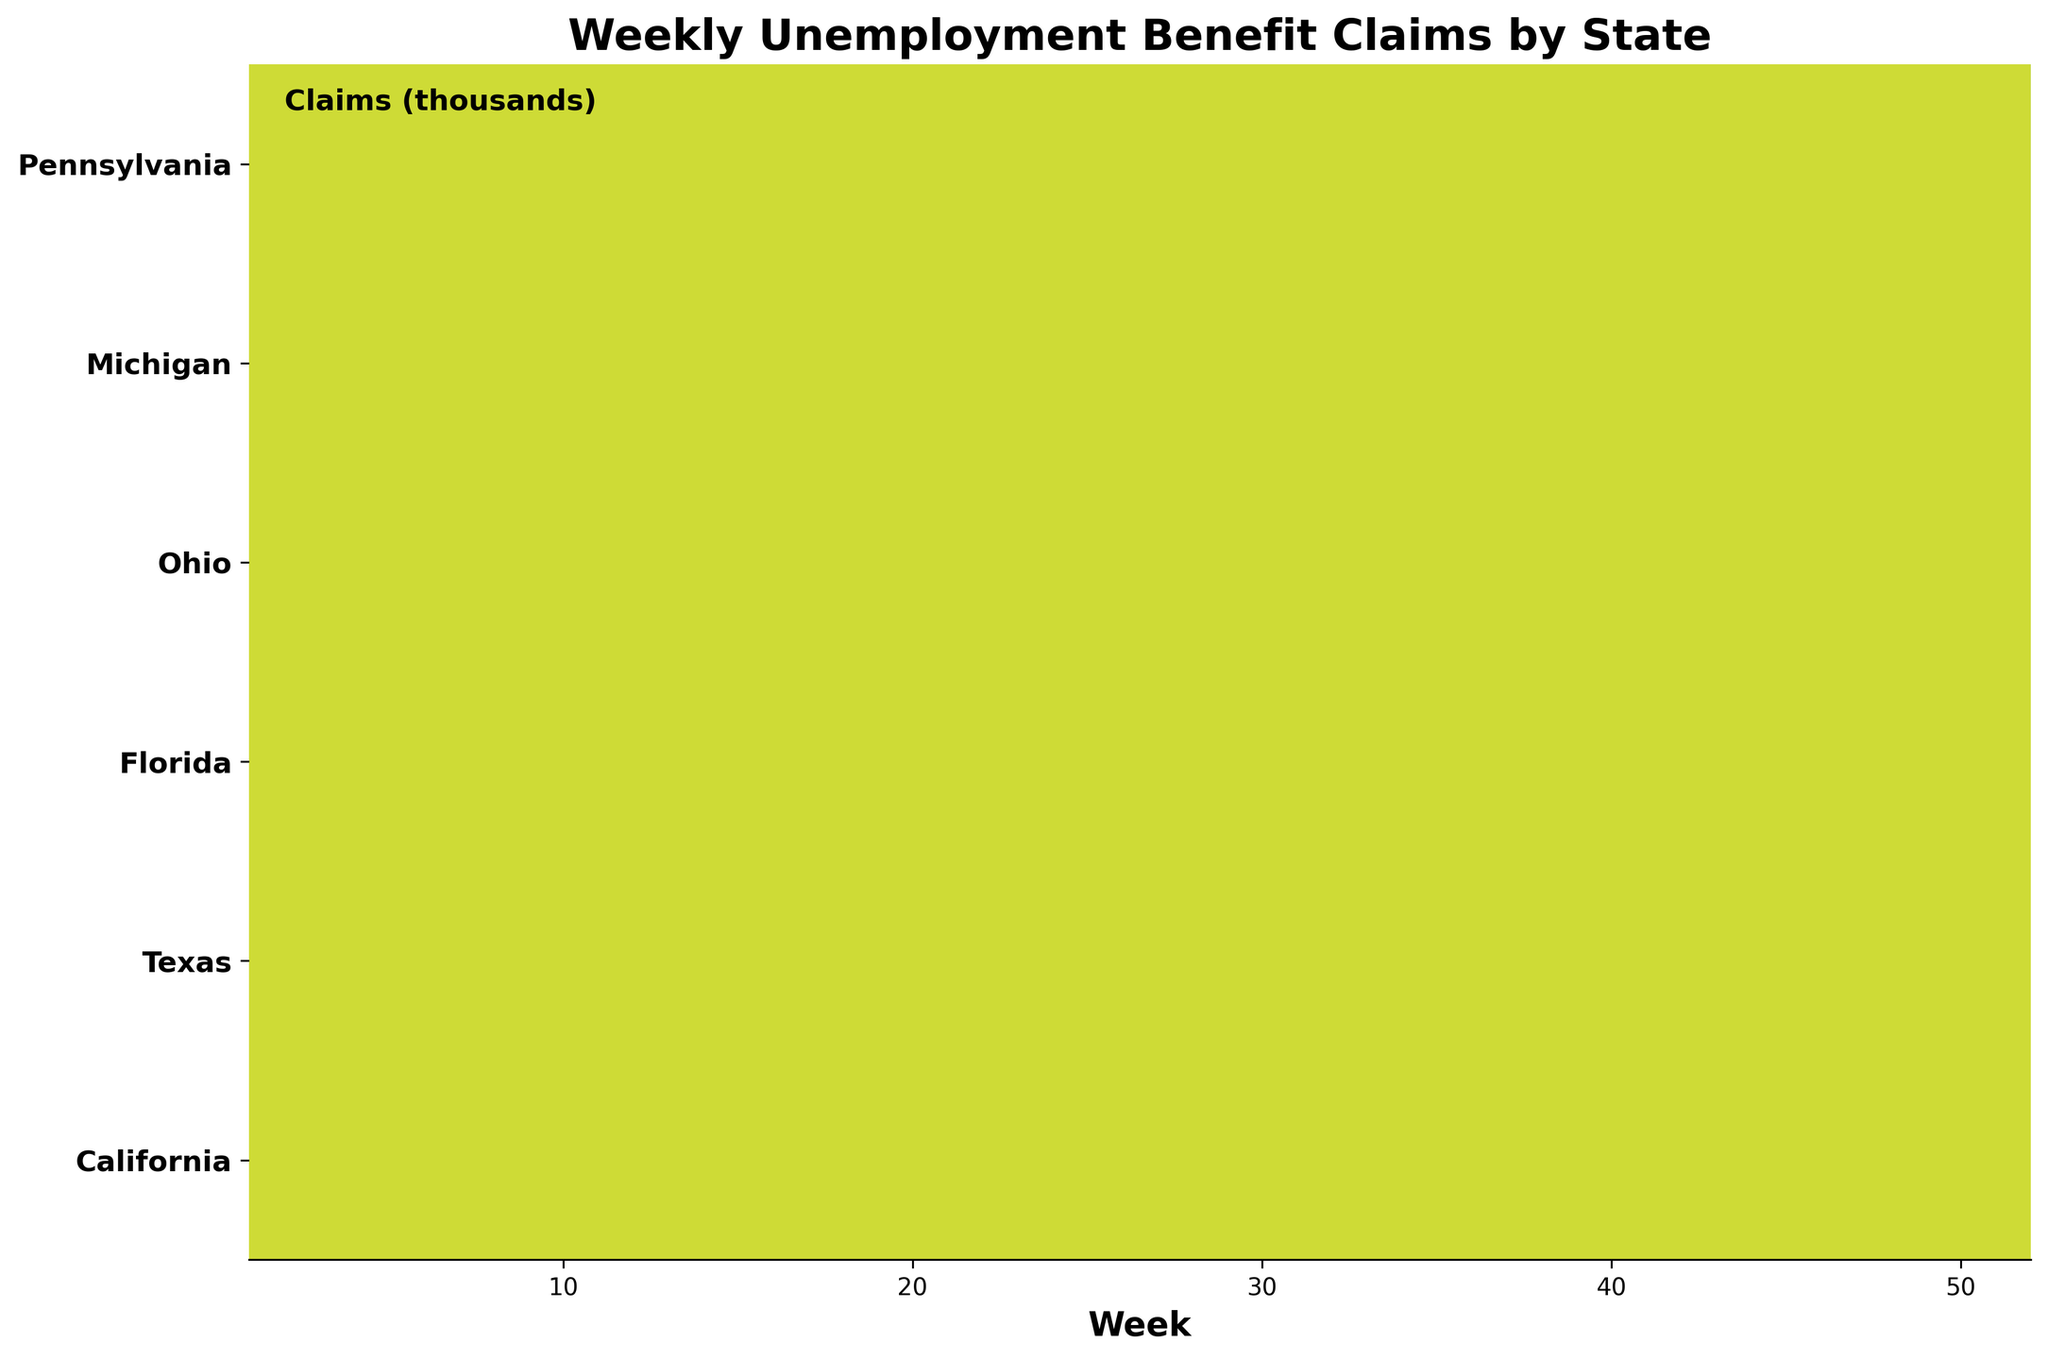How many weeks are represented in the plot? The x-axis of the ridgeline plot represents the weeks, which range from week 1 to week 52. Therefore, there are 52 weeks represented in the plot.
Answer: 52 What state has the highest unemployment benefit claims in week 1? By visual inspection of the ridgeline plot, look for the state with the peak highest along the y-axis at week 1. California appears to have the highest unemployment benefit claims in week 1.
Answer: California Which state shows the greatest variability in unemployment benefit claims over the year? To determine the greatest variability, look for the state whose ridgeline plot has the most significant fluctuations (peaks and troughs). California shows the most significant variability in its plot line, with considerable fluctuations over the year.
Answer: California What is the range of unemployment benefit claims for Texas? The range is computed by subtracting the minimum claims value from the maximum claims value for Texas. The max claim is 35,000 at week 13 and the min claim is 30,000 at week 39. Thus, the range is 35,000 - 30,000.
Answer: 5,000 In which week does Florida have its lowest claims? Check the ridgeline plot for the lowest point of the line corresponding to Florida. Florida shows its lowest claims around week 39.
Answer: 39 Compare the trend of unemployment benefit claims between Ohio and Michigan. Which state shows a more significant decline? By visually comparing the line trends of Ohio and Michigan, observe the general direction of the lines. Both states show a downward trend, but Ohio has a more marked decline from 20,000 to 17,000 compared to Michigan from 18,000 to 16,500.
Answer: Ohio Approximately how many claims does Pennsylvania have in week 52? Look at where the line for Pennsylvania intersects with week 52 on the x-axis and check the corresponding y-value. Pennsylvania has around 20,500 claims in week 52.
Answer: 20,500 Which state consistently has the lowest number of claims each week? By examining the overall position of the ridgeline plots, Michigan consistently appears lower across the weeks compared to the other states.
Answer: Michigan What is the average number of claims over the year for California? Sum the weekly claims for California (45,000 + 52,000 + 48,000 + 43,000 + 46,000) and divide by the number of weeks (5). So, (45,000 + 52,000 + 48,000 + 43,000 + 46,000) / 5 = 234,000 / 5 = 46,800.
Answer: 46,800 Is there a state where the claims increase at the end of the year compared to the beginning? To find an increasing trend, compare the claims at the start and end of the plots. Texas shows a slight increase from 32,000 in week 1 to 31,000 in week 52.
Answer: No 